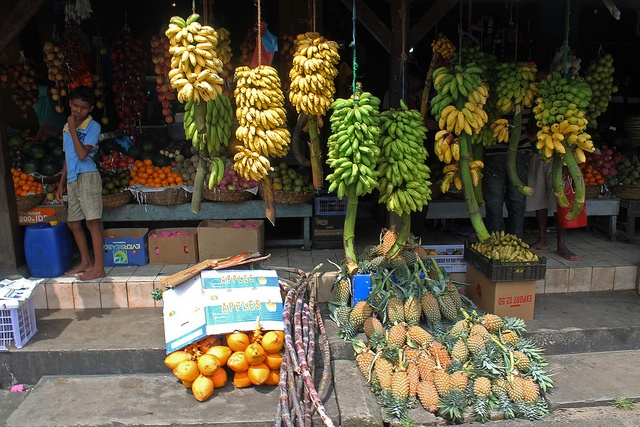Describe the objects in this image and their specific colors. I can see people in black, gray, and maroon tones, banana in black, darkgreen, and green tones, banana in black, darkgreen, and olive tones, banana in black, olive, ivory, and orange tones, and banana in black, olive, khaki, and orange tones in this image. 